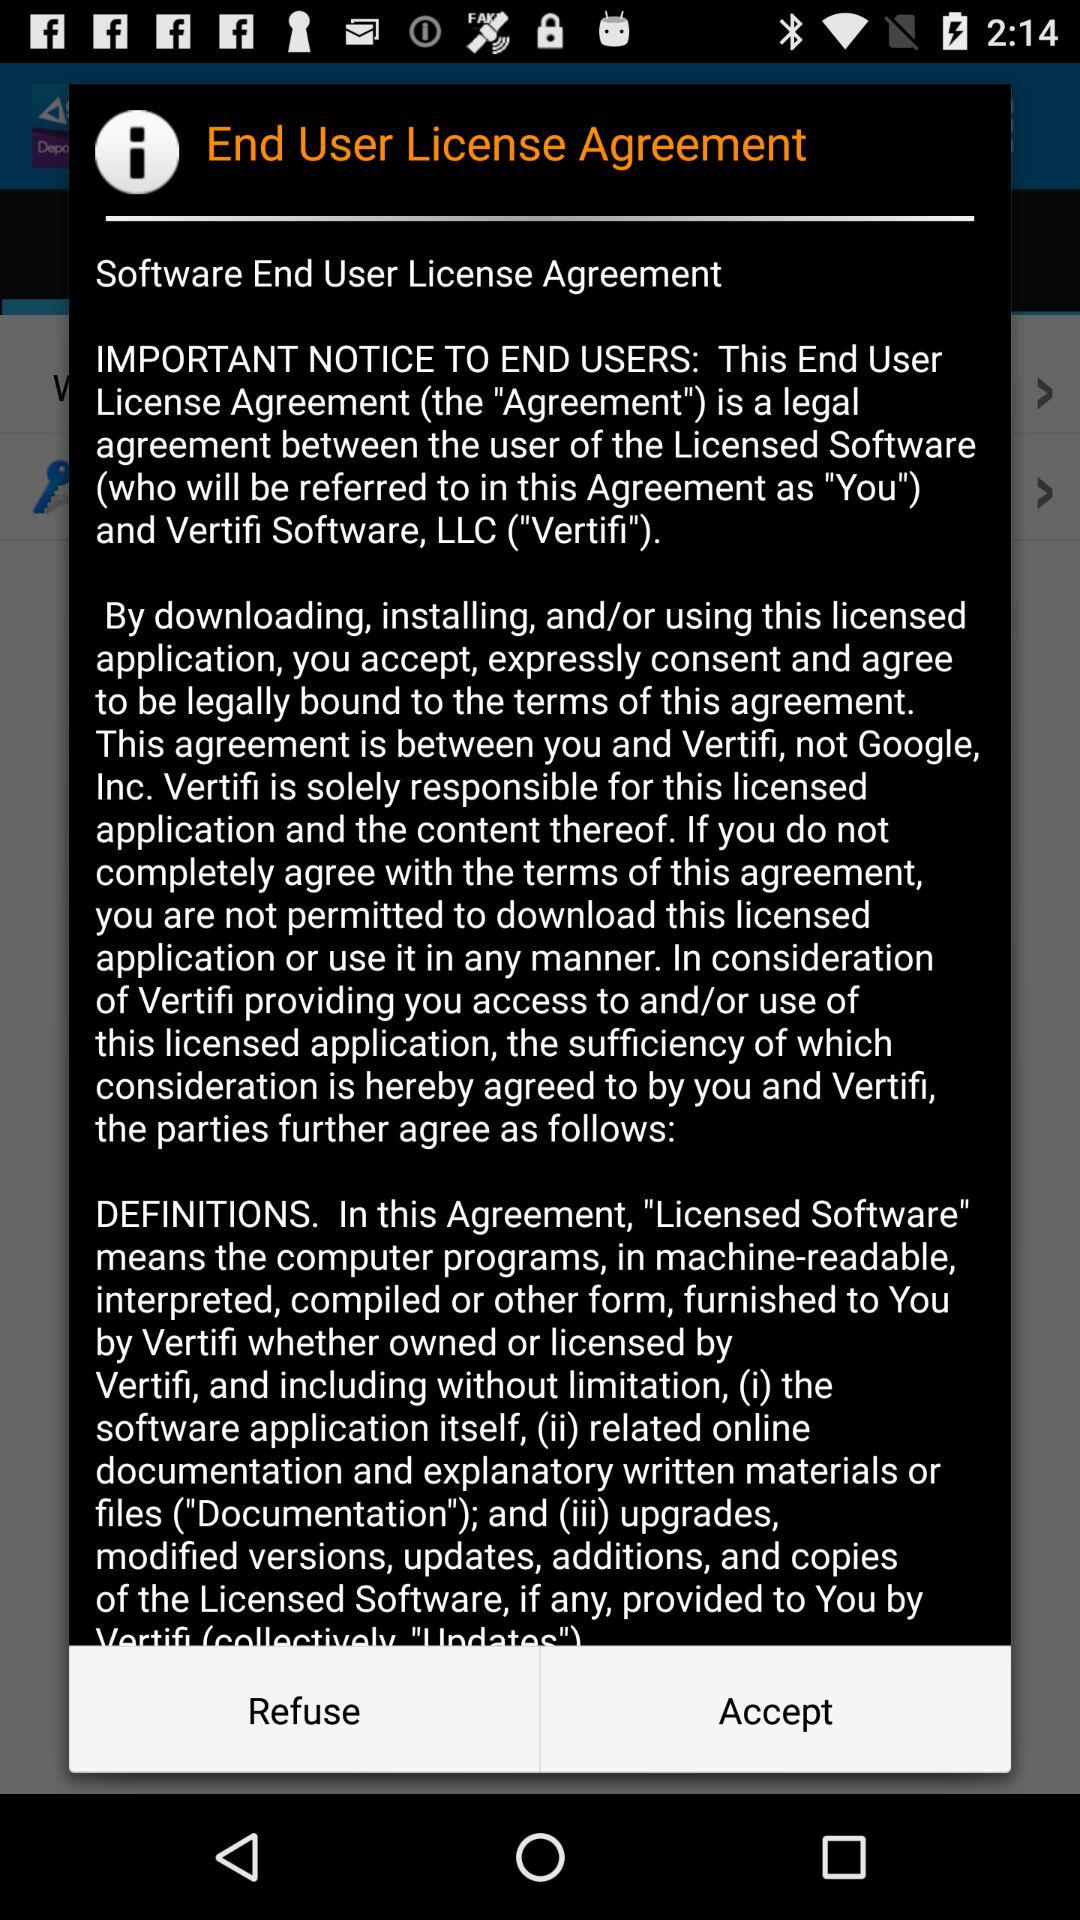How many terms are included in the definition of Licensed Software?
Answer the question using a single word or phrase. 3 